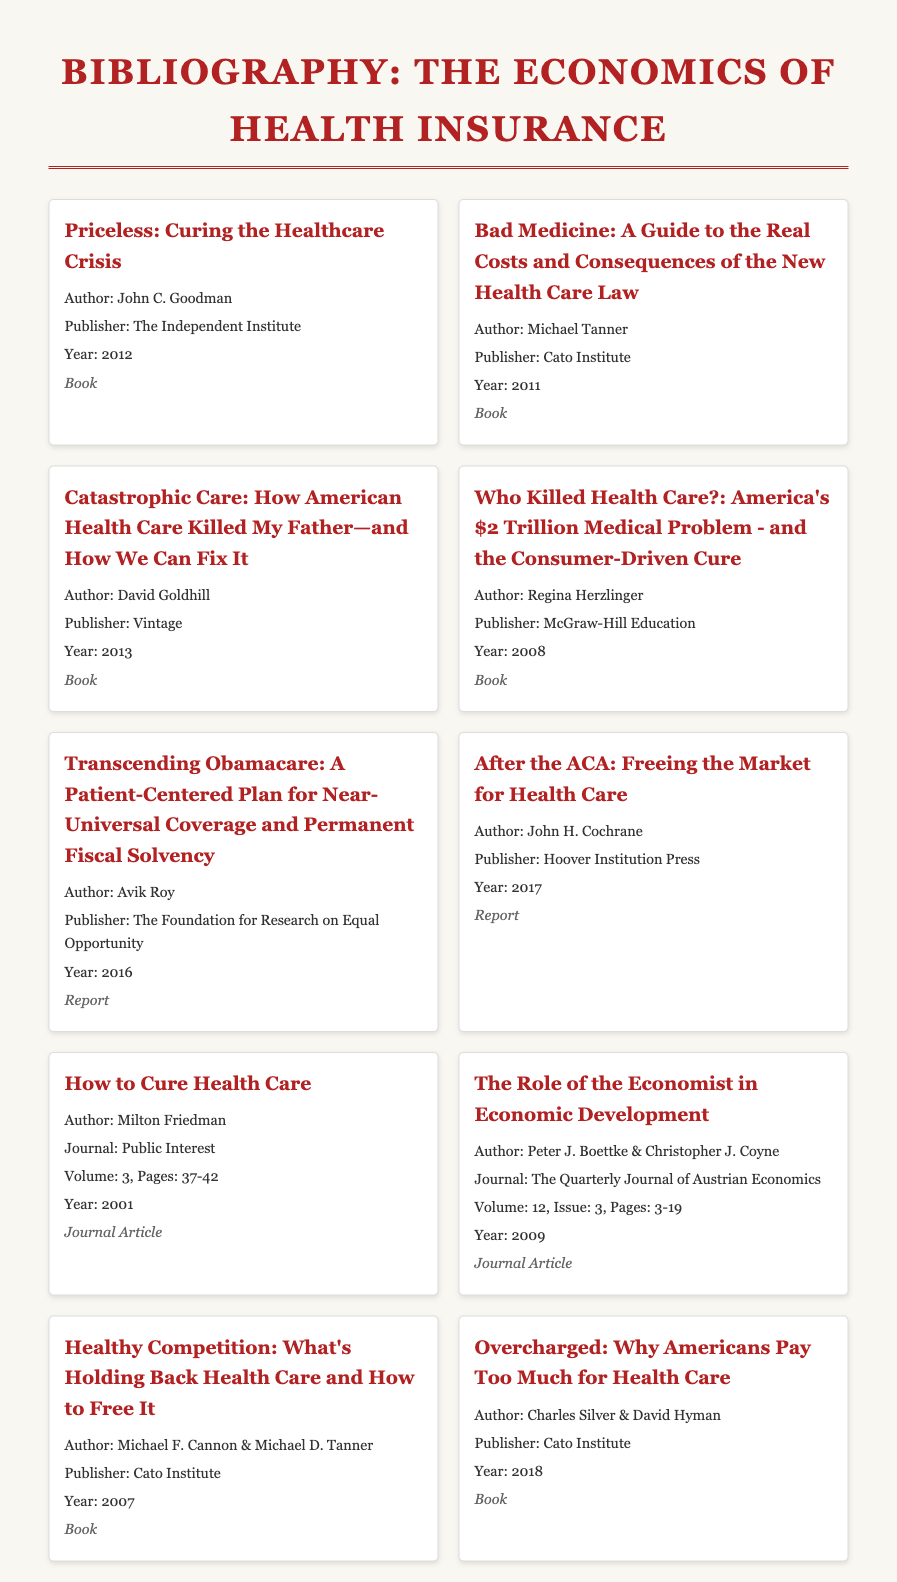What is the title of the first book? The title is the first entry in the bibliography, which is "Priceless: Curing the Healthcare Crisis."
Answer: Priceless: Curing the Healthcare Crisis Who is the author of "Catastrophic Care"? The author of "Catastrophic Care" is mentioned in the bibliography entry for that book, which is David Goldhill.
Answer: David Goldhill What year was "Overcharged" published? The publication year can be found in the entry for "Overcharged," which states it was published in 2018.
Answer: 2018 Which publisher produced "Bad Medicine"? The publisher is listed in the respective entry of the bibliography as Cato Institute.
Answer: Cato Institute How many journal articles are listed in the bibliography? The total journal articles can be counted from the bibliography, which lists two journal articles.
Answer: 2 Which entry has a volume number associated with it? The entry for "How to Cure Health Care" lists a volume number, indicating it is a journal article.
Answer: Volume 3 What is the primary focus of "Healthy Competition"? This is determined by examining the title and entry, which suggests it discusses health care competition.
Answer: Competition Who are the authors of "The Role of the Economist in Economic Development"? The authors are mentioned in the bibliography entry as Peter J. Boettke & Christopher J. Coyne.
Answer: Peter J. Boettke & Christopher J. Coyne What type of document is "Transcending Obamacare"? The type of document is specified in the entry and is noted as a report.
Answer: Report 